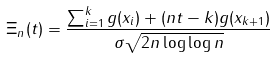<formula> <loc_0><loc_0><loc_500><loc_500>\Xi _ { n } ( t ) = \frac { \sum _ { i = 1 } ^ { k } g ( x _ { i } ) + ( n t - k ) g ( x _ { k + 1 } ) } { \sigma \sqrt { 2 n \log \log n } }</formula> 